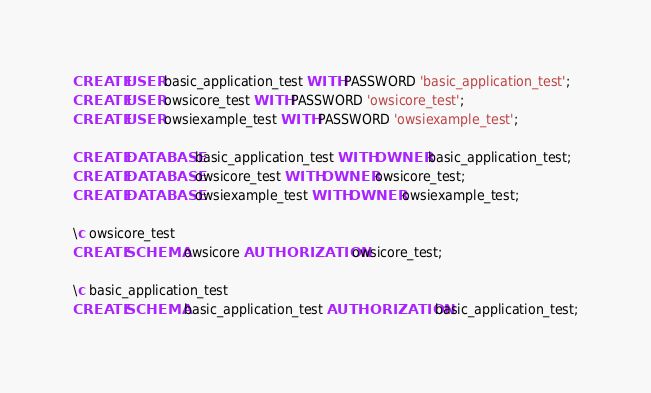<code> <loc_0><loc_0><loc_500><loc_500><_SQL_>CREATE USER basic_application_test WITH PASSWORD 'basic_application_test';
CREATE USER owsicore_test WITH PASSWORD 'owsicore_test';
CREATE USER owsiexample_test WITH PASSWORD 'owsiexample_test';

CREATE DATABASE basic_application_test WITH OWNER basic_application_test;
CREATE DATABASE owsicore_test WITH OWNER owsicore_test;
CREATE DATABASE owsiexample_test WITH OWNER owsiexample_test;

\c owsicore_test
CREATE SCHEMA owsicore AUTHORIZATION owsicore_test;

\c basic_application_test
CREATE SCHEMA basic_application_test AUTHORIZATION basic_application_test;
</code> 